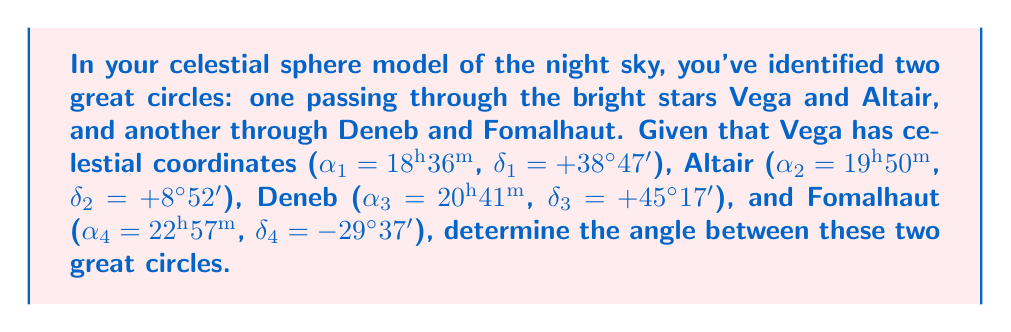Help me with this question. To find the angle between two great circles on a sphere, we can use the formula for the angle between two vectors in 3D space. The process is as follows:

1. Convert celestial coordinates (right ascension α and declination δ) to Cartesian coordinates:
   $x = \cos δ \cos α$
   $y = \cos δ \sin α$
   $z = \sin δ$

   Note: Convert right ascension from hours to radians (multiply by π/12)

2. Calculate the normal vectors to each great circle:
   $\vec{n_1} = \vec{v_1} \times \vec{v_2}$ (for Vega-Altair)
   $\vec{n_2} = \vec{v_3} \times \vec{v_4}$ (for Deneb-Fomalhaut)

3. Find the angle θ between the normal vectors:
   $\cos θ = \frac{\vec{n_1} \cdot \vec{n_2}}{|\vec{n_1}||\vec{n_2}|}$

Step 1: Convert coordinates
Vega: $α₁ = 18.6π/12 = 4.8690$ rad, $δ₁ = 38.7833°π/180 = 0.6768$ rad
$\vec{v_1} = (0.1921, 0.7721, 0.6255)$

Altair: $α₂ = 19.8333π/12 = 5.1837$ rad, $δ₂ = 8.8667°π/180 = 0.1547$ rad
$\vec{v_2} = (-0.0656, 0.9635, 0.1544)$

Deneb: $α₃ = 20.6833π/12 = 5.4151$ rad, $δ₃ = 45.2833°π/180 = 0.7904$ rad
$\vec{v_3} = (-0.1911, 0.6687, 0.7188)$

Fomalhaut: $α₄ = 22.95π/12 = 6.0107$ rad, $δ₄ = -29.6167°π/180 = -0.5169$ rad
$\vec{v_4} = (0.3238, -0.8288, -0.4561)$

Step 2: Calculate normal vectors
$\vec{n_1} = \vec{v_1} \times \vec{v_2} = (-0.7034, 0.1390, 0.6971)$
$\vec{n_2} = \vec{v_3} \times \vec{v_4} = (0.5690, 0.6876, -0.4515)$

Step 3: Find the angle
$\cos θ = \frac{\vec{n_1} \cdot \vec{n_2}}{|\vec{n_1}||\vec{n_2}|} = \frac{-0.4006 + 0.0956 - 0.3148}{\sqrt{1.0000}\sqrt{1.0000}} = -0.6198$

$θ = \arccos(-0.6198) = 2.2322$ rad = 127.9°
Answer: 127.9° 